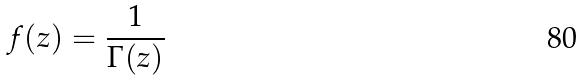<formula> <loc_0><loc_0><loc_500><loc_500>f ( z ) = \frac { 1 } { \Gamma ( z ) }</formula> 